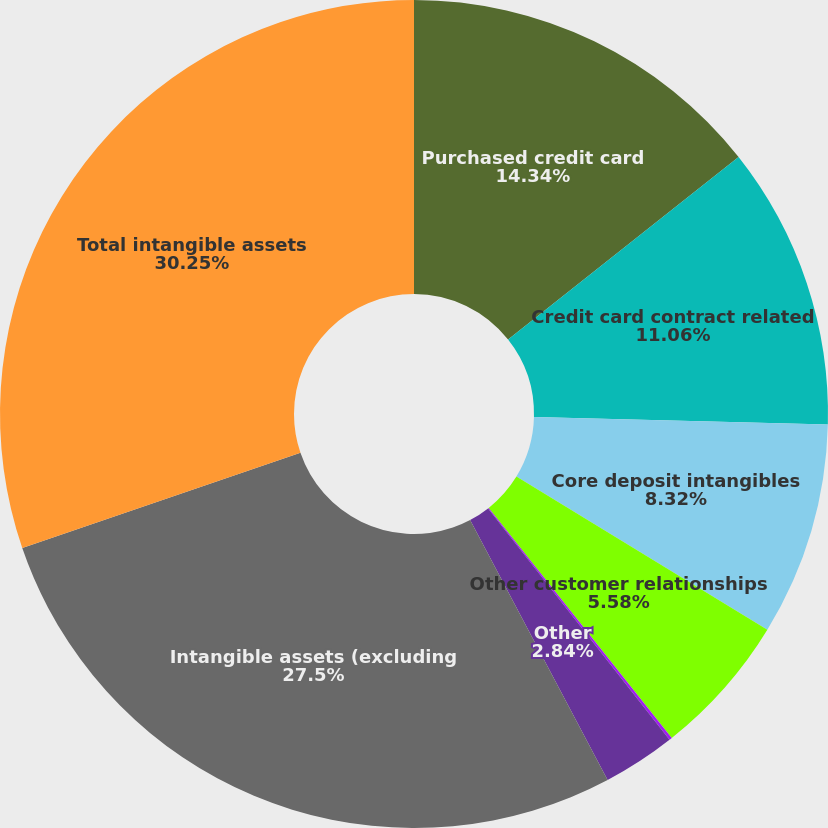<chart> <loc_0><loc_0><loc_500><loc_500><pie_chart><fcel>Purchased credit card<fcel>Credit card contract related<fcel>Core deposit intangibles<fcel>Other customer relationships<fcel>Present value of future<fcel>Other<fcel>Intangible assets (excluding<fcel>Total intangible assets<nl><fcel>14.34%<fcel>11.06%<fcel>8.32%<fcel>5.58%<fcel>0.11%<fcel>2.84%<fcel>27.5%<fcel>30.24%<nl></chart> 